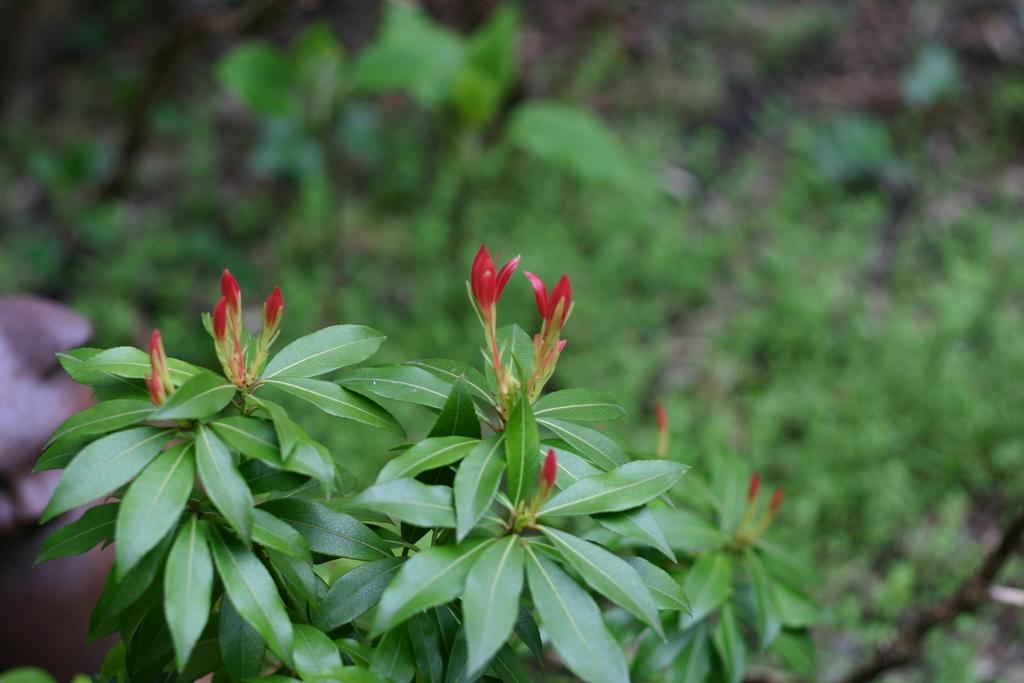What type of plant can be seen with flowers in the image? There is a plant with flowers in the image. Can you describe the other plant visible in the image? There is another plant visible in the image. What type of force is being exerted on the plants in the image? There is no indication of any force being exerted on the plants in the image. How many sisters are present in the image? There are no people, let alone sisters, present in the image; it only features plants. 